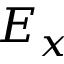<formula> <loc_0><loc_0><loc_500><loc_500>E _ { x }</formula> 